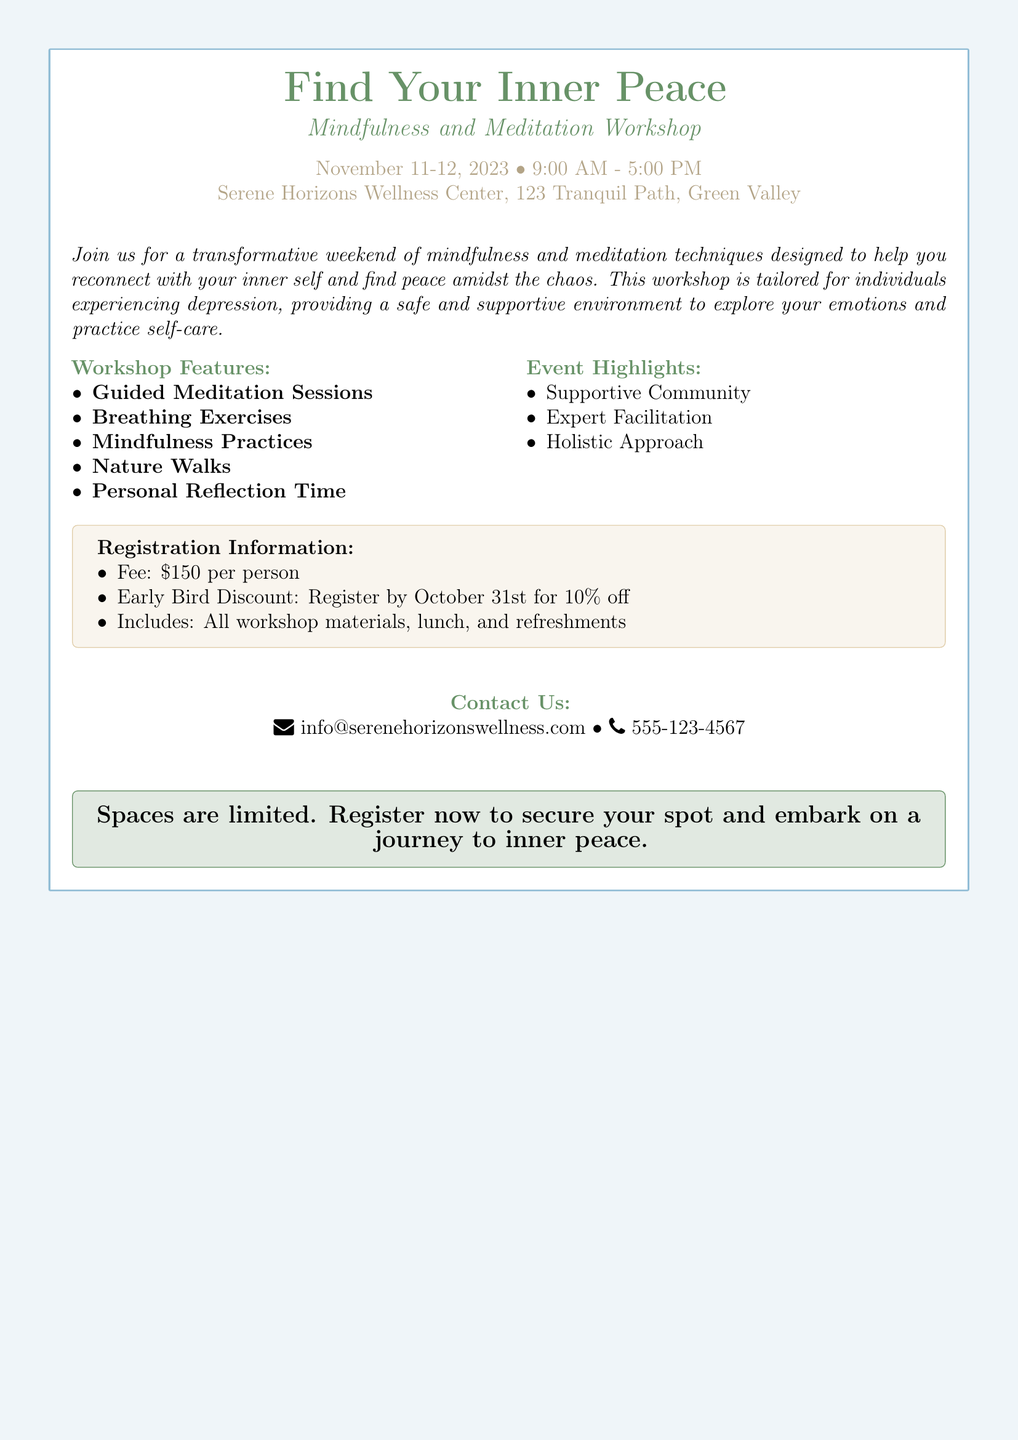What are the dates of the workshop? The dates of the workshop are listed as November 11-12, 2023.
Answer: November 11-12, 2023 What is the workshop fee? The fee for the workshop is explicitly stated in the document as $150 per person.
Answer: $150 What time does the workshop start? The starting time for the workshop is indicated as 9:00 AM.
Answer: 9:00 AM What feature includes personal time? The document mentions "Personal Reflection Time" as a feature of the workshop.
Answer: Personal Reflection Time What discount is offered if registered by a specific date? The document specifies a 10% discount for registering by October 31st.
Answer: 10% off Which item highlights a community aspect? The document highlights "Supportive Community" under the event highlights section.
Answer: Supportive Community What is the location of the workshop? The location is provided as Serene Horizons Wellness Center, 123 Tranquil Path, Green Valley.
Answer: Serene Horizons Wellness Center, 123 Tranquil Path, Green Valley What type of exercises will be conducted? The workshop will feature "Breathing Exercises" as mentioned in the features.
Answer: Breathing Exercises 